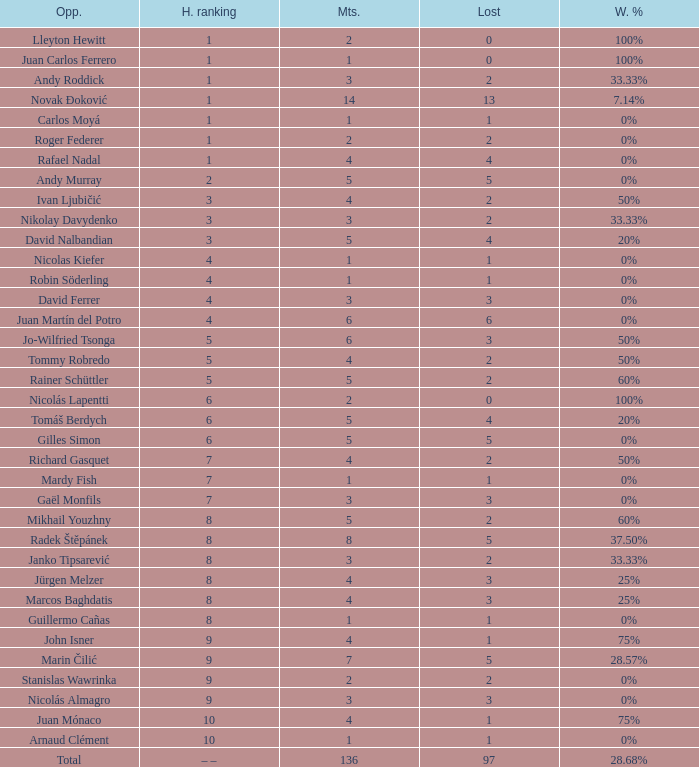What is the smallest number of Matches with less than 97 losses and a Win rate of 28.68%? None. 